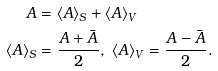Convert formula to latex. <formula><loc_0><loc_0><loc_500><loc_500>A & = \left \langle A \right \rangle _ { S } + \left \langle A \right \rangle _ { V } \\ \left \langle A \right \rangle _ { S } & = \frac { A + \bar { A } } { 2 } , \ \left \langle A \right \rangle _ { V } = \frac { A - \bar { A } } { 2 } .</formula> 